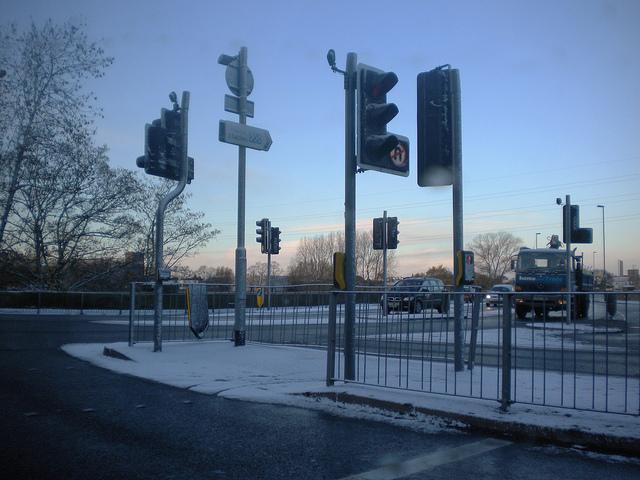What are drivers told is forbidden?
Indicate the correct response by choosing from the four available options to answer the question.
Options: Go straight, turn left, u-turns, yield. U-turns. 